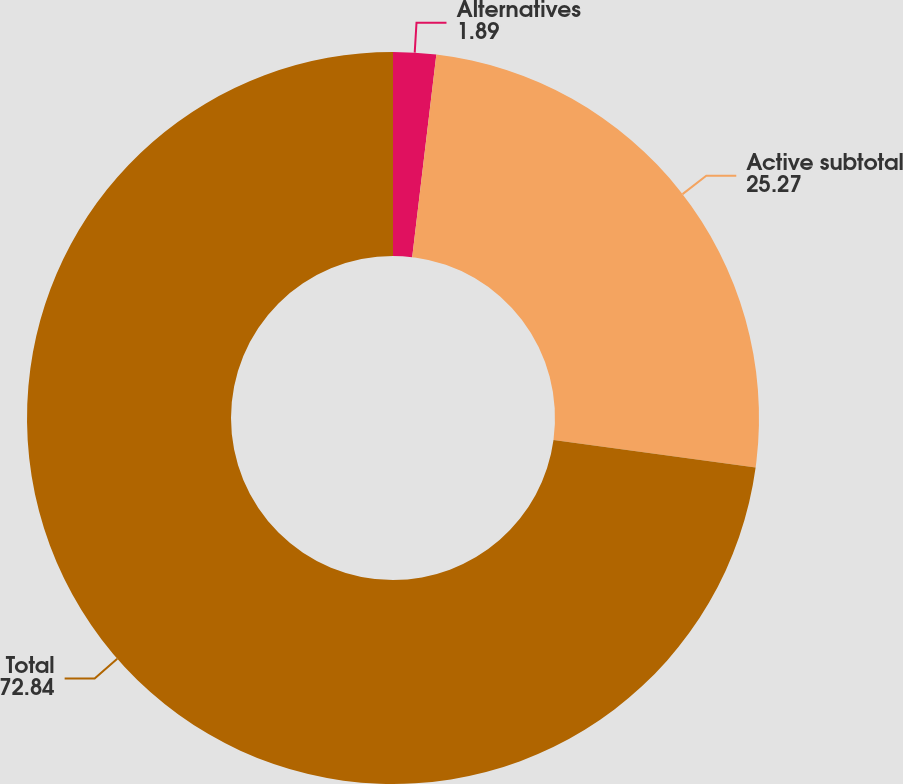Convert chart. <chart><loc_0><loc_0><loc_500><loc_500><pie_chart><fcel>Alternatives<fcel>Active subtotal<fcel>Total<nl><fcel>1.89%<fcel>25.27%<fcel>72.84%<nl></chart> 